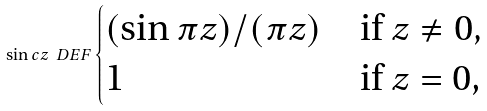Convert formula to latex. <formula><loc_0><loc_0><loc_500><loc_500>\sin c z \ D E F \begin{cases} ( \sin \pi z ) / ( \pi z ) & \text {if $z\neq0,$} \\ 1 & \text {if $z=0$,} \end{cases}</formula> 